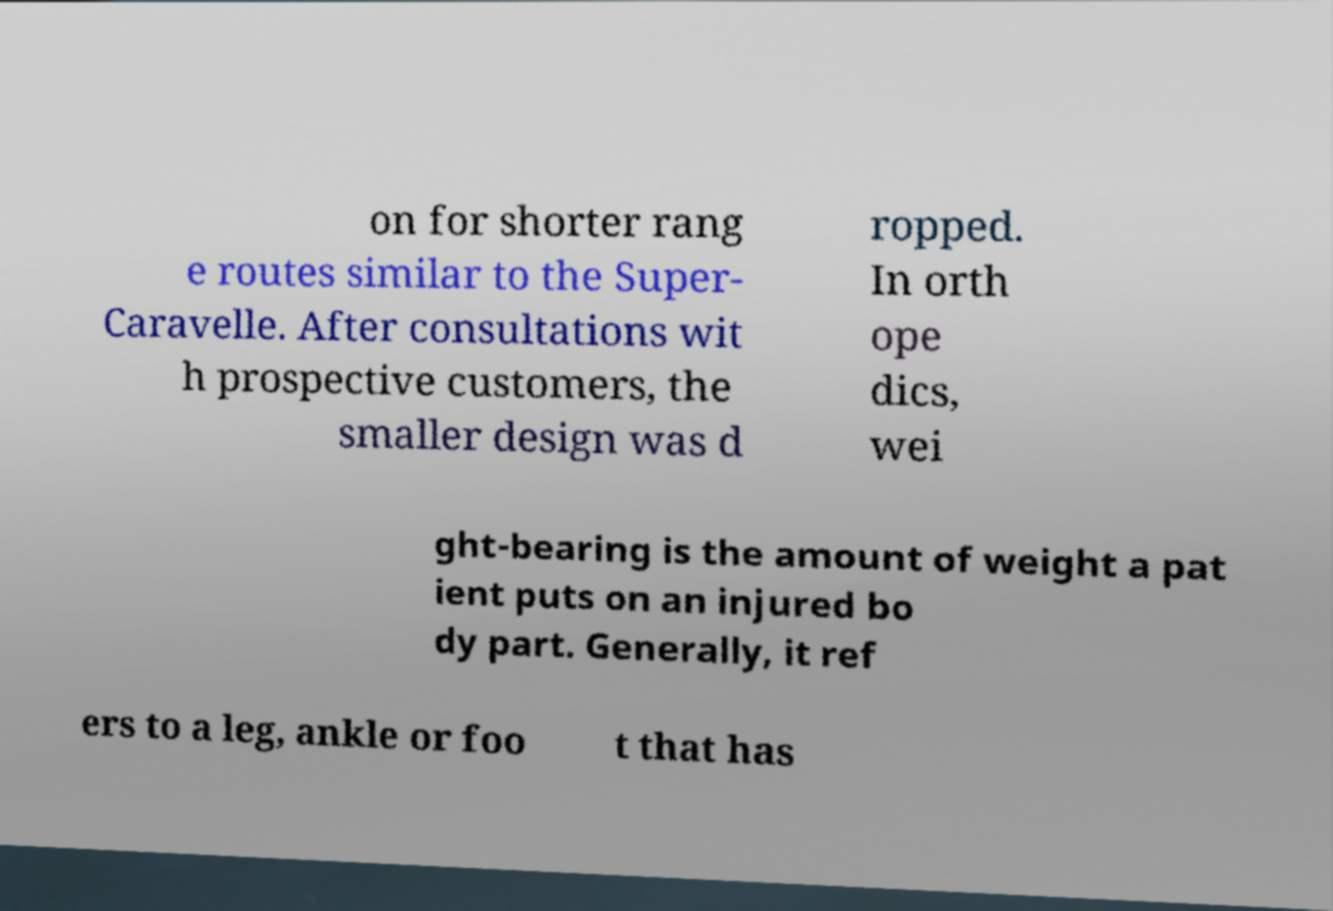What messages or text are displayed in this image? I need them in a readable, typed format. on for shorter rang e routes similar to the Super- Caravelle. After consultations wit h prospective customers, the smaller design was d ropped. In orth ope dics, wei ght-bearing is the amount of weight a pat ient puts on an injured bo dy part. Generally, it ref ers to a leg, ankle or foo t that has 